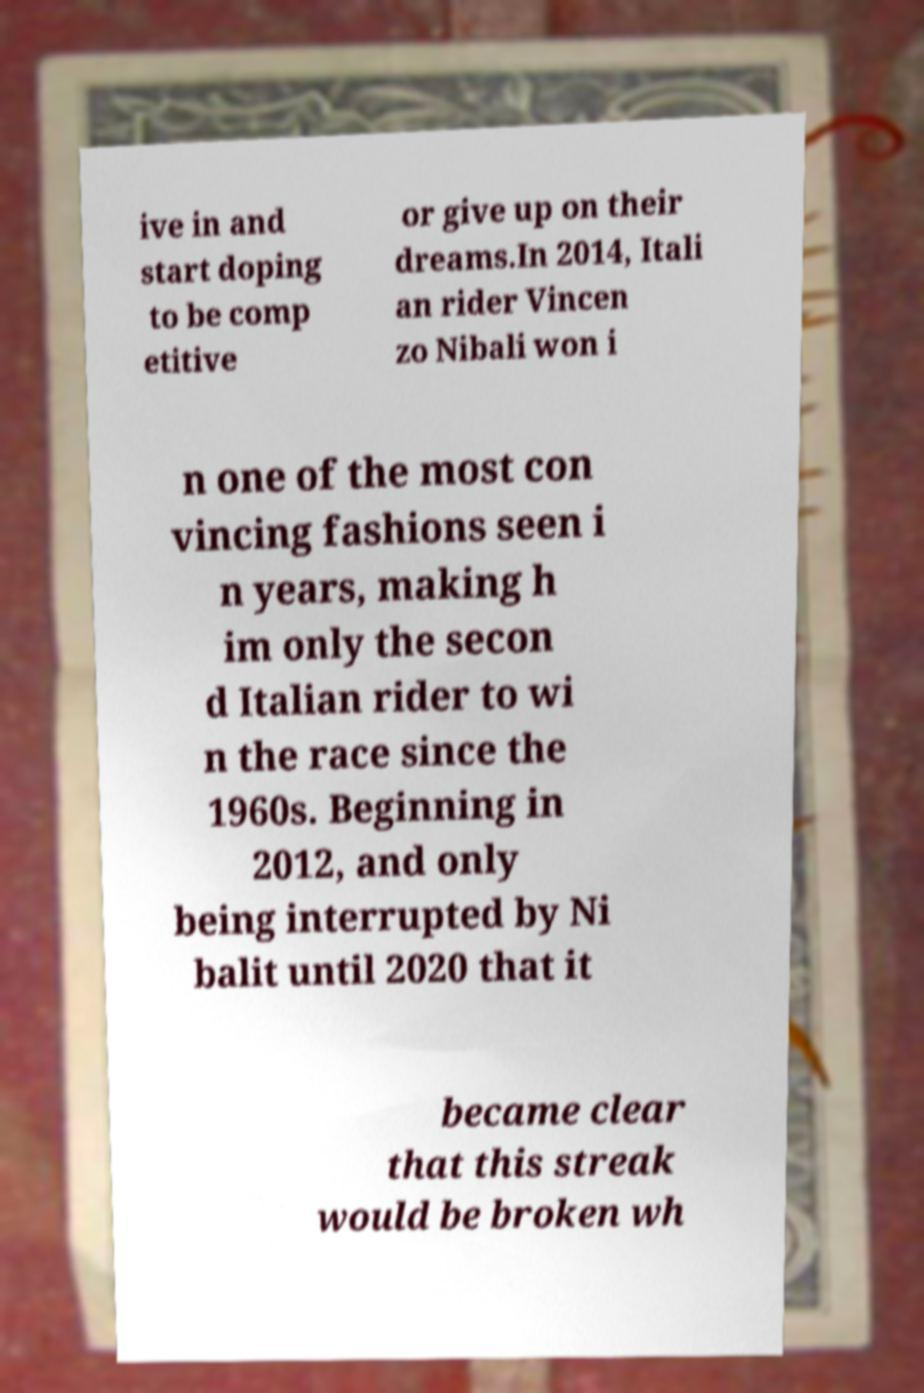Could you assist in decoding the text presented in this image and type it out clearly? ive in and start doping to be comp etitive or give up on their dreams.In 2014, Itali an rider Vincen zo Nibali won i n one of the most con vincing fashions seen i n years, making h im only the secon d Italian rider to wi n the race since the 1960s. Beginning in 2012, and only being interrupted by Ni balit until 2020 that it became clear that this streak would be broken wh 